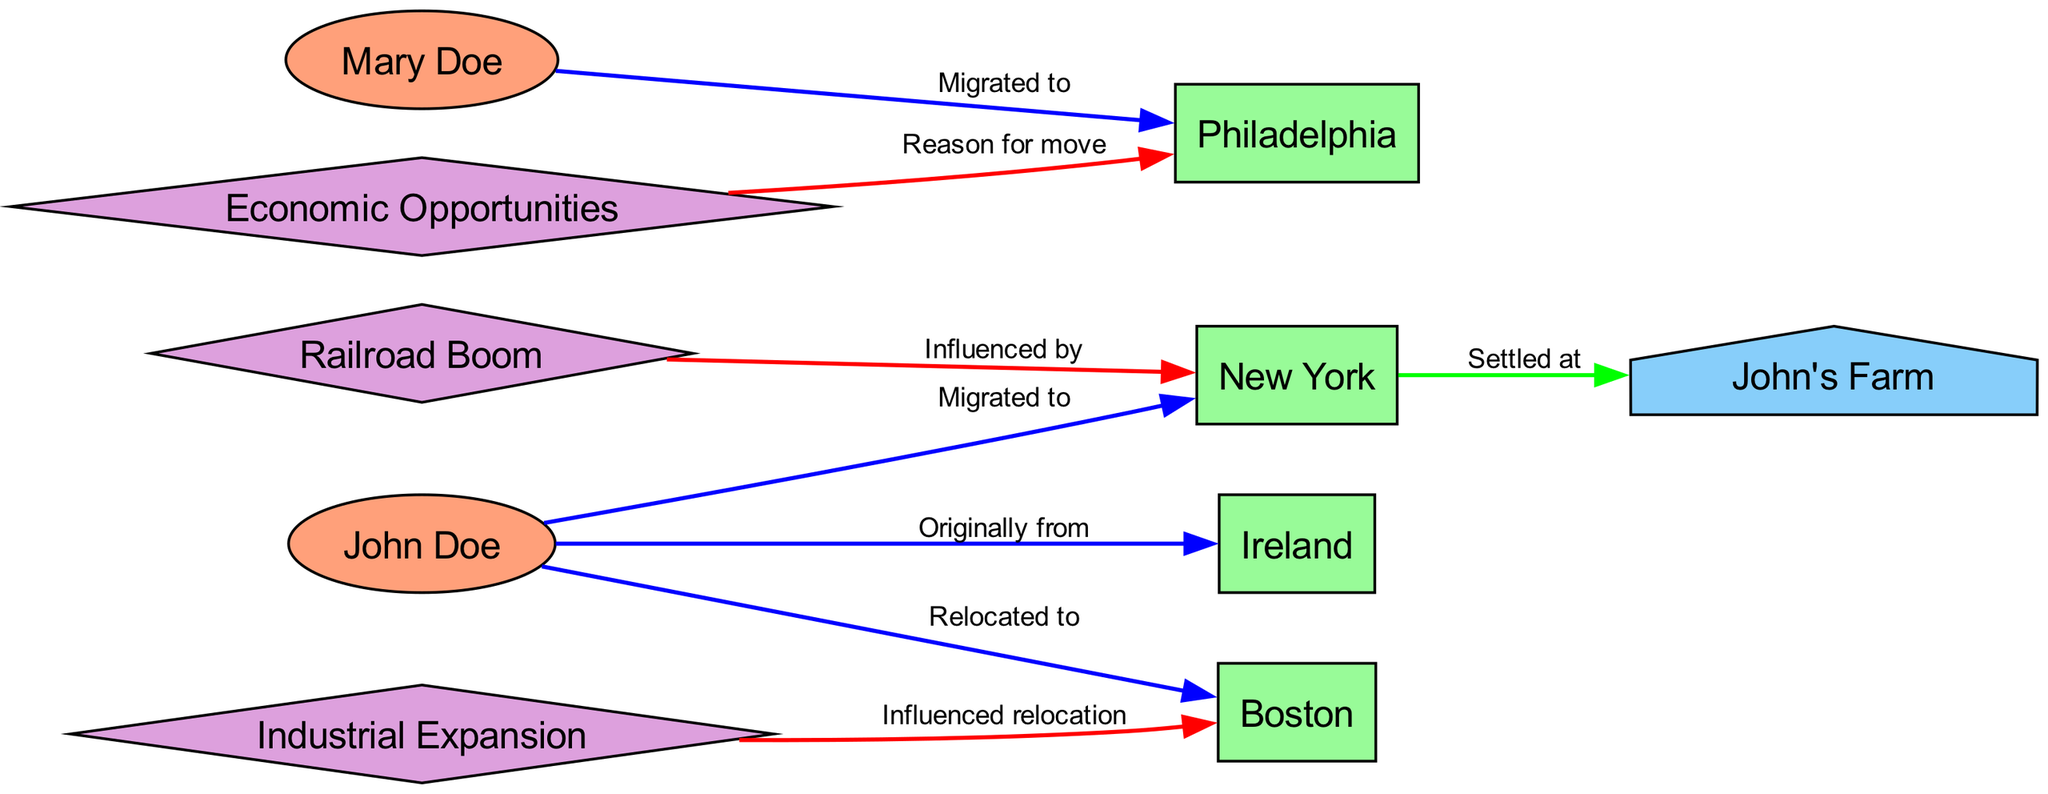What is the original homeland of the Doe family? The diagram states that the Doe family originally comes from Ireland, as indicated by the edge connecting John Doe to Ireland labeled "Originally from".
Answer: Ireland How many migration events are shown in the diagram? By examining the edges related to migration, there are three migration events: John Doe to New York, John Doe to Boston, and Mary Doe to Philadelphia.
Answer: 3 What influenced the Doe family's migration to New York? The diagram specifically states that the Railroad Boom influenced the migration to New York, as reflected by the edge connecting Railroad Boom to New York labeled "Influenced by".
Answer: Railroad Boom Where did Mary Doe migrate to? The diagram shows that Mary Doe migrated to Philadelphia, indicated by the edge connecting Mary Doe to Philadelphia labeled "Migrated to".
Answer: Philadelphia Which factor prompted the Doe family's relocation to Boston? The diagram identifies Industrial Expansion as the influencing factor for relocation to Boston, shown by the edge connecting Industrial Expansion to Boston labeled "Influenced relocation".
Answer: Industrial Expansion What property did John Doe settle at in New York? The settlement information in the diagram indicates that John Doe settled at John's Farm in upstate New York, as seen in the edge connecting New York to John's Farm labeled "Settled at".
Answer: John's Farm Which location is the secondary settlement for the Doe family? The diagram indicates that Boston serves as the secondary settlement for the Doe family after New York, illustrated by the direct connection from John Doe to Boston labeled "Relocated to".
Answer: Boston What was the reason for Mary Doe's move to Philadelphia? The edge connecting Economic Opportunities to Philadelphia labeled "Reason for move" clarifies that Economic Opportunities was the reason for Mary Doe's migration.
Answer: Economic Opportunities Who is the patriarch of the Doe family? The diagram clearly identifies John Doe as the patriarch of the Doe family, denoted in his description within the person nodal structure.
Answer: John Doe 